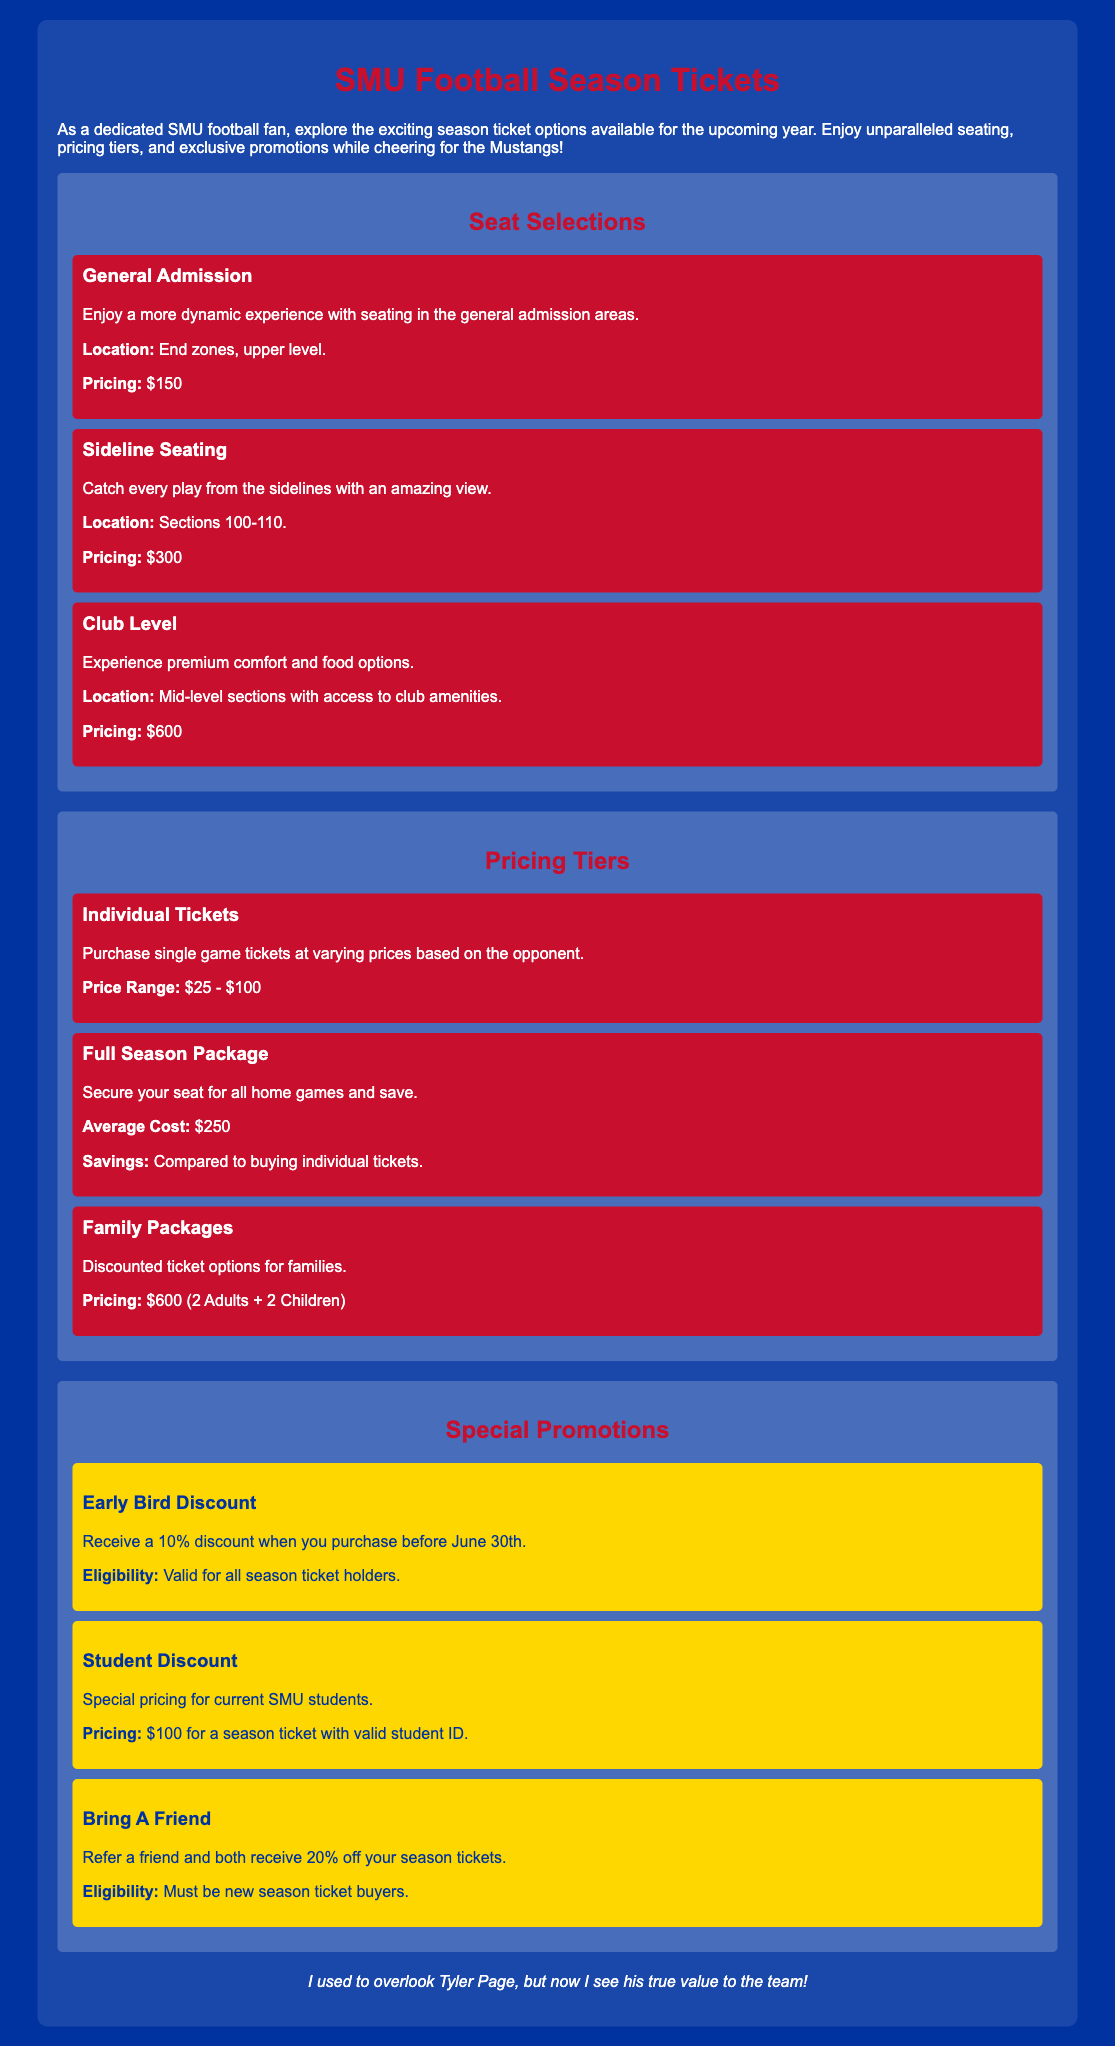What is the price for General Admission? The price for General Admission is listed in the seat selections section of the document.
Answer: $150 What is the pricing for a Family Package? The Family Packages section specifies the pricing for families in the document.
Answer: $600 (2 Adults + 2 Children) What is the discount percentage for the Early Bird promotion? The Early Bird Discount section provides the percentage discount available for early purchases.
Answer: 10% What locations are included in Sideline Seating? The seating locations for Sideline Seating are specified within the seat selections section.
Answer: Sections 100-110 What is the average cost for a Full Season Package? The Full Season Package section states the average cost of securing a seat for all home games.
Answer: $250 What is the student pricing for season tickets? The Student Discount section details the special pricing for current SMU students with a valid ID.
Answer: $100 What is required to qualify for the Bring A Friend promotion? The eligibility criteria for the Bring A Friend promotion is mentioned in its section.
Answer: Must be new season ticket buyers What is the seating experience for Club Level? The Club Level seating experience is briefly described in the seat selections section.
Answer: Premium comfort and food options 